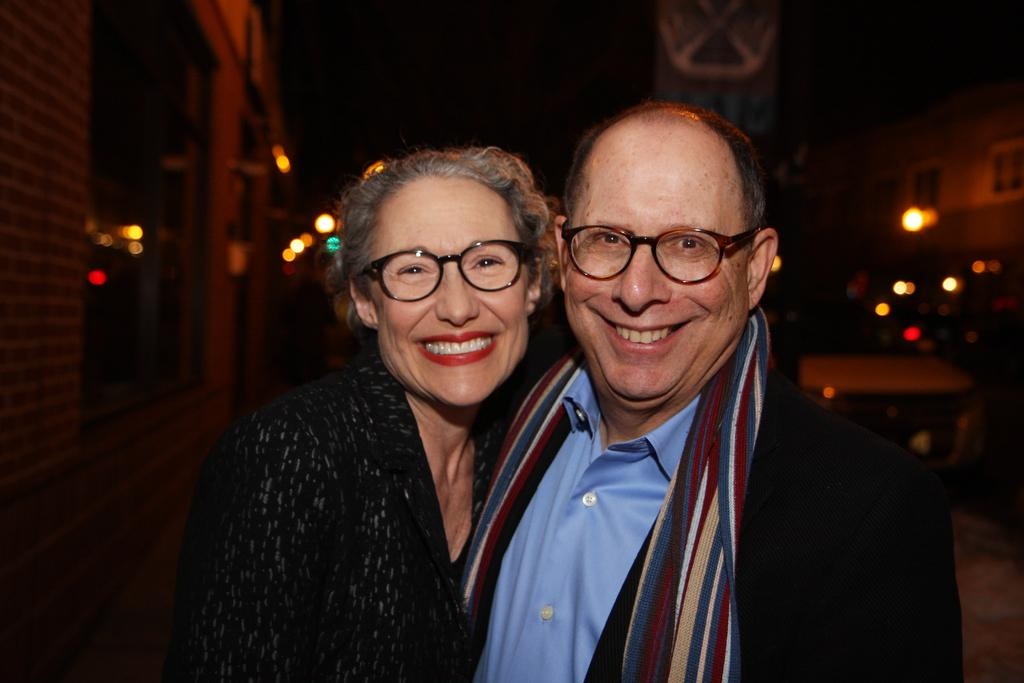How many people are in the image? There are two people in the image, a lady and a man. What are the lady and the man doing in the image? Both the lady and the man are standing and smiling. What can be seen in the background of the image? There are buildings and lights in the background of the image. What type of stretching activity is the lady participating in with the man in the image? There is no stretching activity or game present in the image; the lady and the man are simply standing and smiling. 